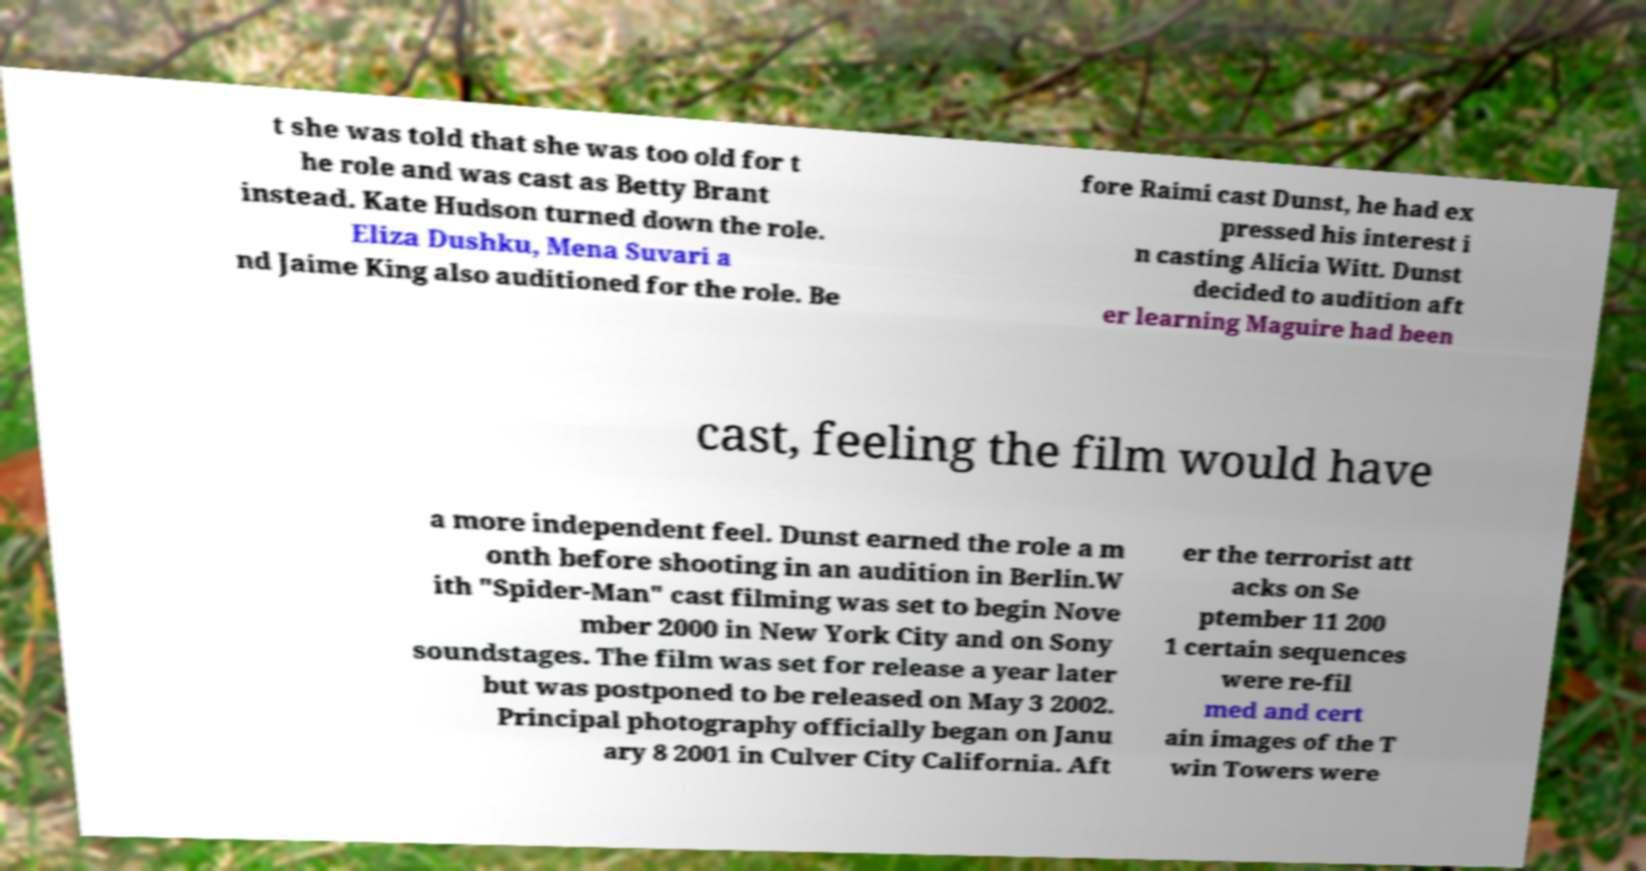Please identify and transcribe the text found in this image. t she was told that she was too old for t he role and was cast as Betty Brant instead. Kate Hudson turned down the role. Eliza Dushku, Mena Suvari a nd Jaime King also auditioned for the role. Be fore Raimi cast Dunst, he had ex pressed his interest i n casting Alicia Witt. Dunst decided to audition aft er learning Maguire had been cast, feeling the film would have a more independent feel. Dunst earned the role a m onth before shooting in an audition in Berlin.W ith "Spider-Man" cast filming was set to begin Nove mber 2000 in New York City and on Sony soundstages. The film was set for release a year later but was postponed to be released on May 3 2002. Principal photography officially began on Janu ary 8 2001 in Culver City California. Aft er the terrorist att acks on Se ptember 11 200 1 certain sequences were re-fil med and cert ain images of the T win Towers were 